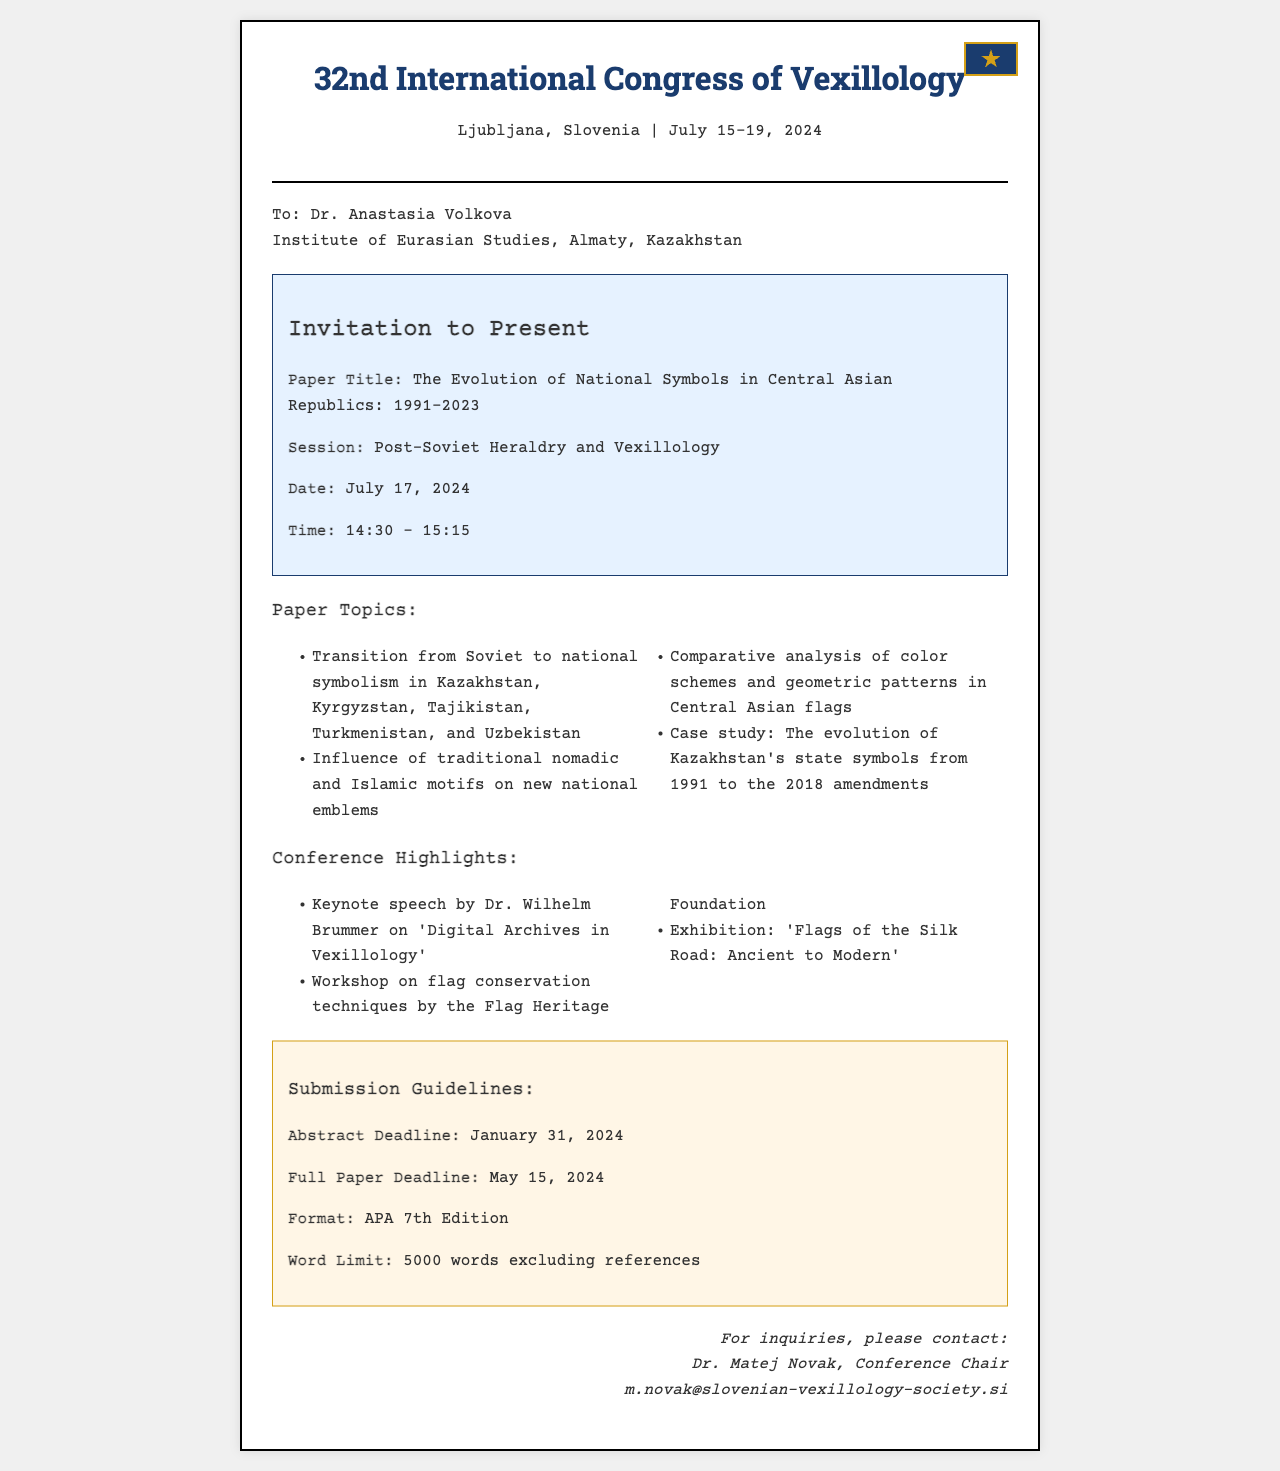What is the paper title? The title of the paper is mentioned in the invitation details as "The Evolution of National Symbols in Central Asian Republics: 1991-2023."
Answer: The Evolution of National Symbols in Central Asian Republics: 1991-2023 Who is the recipient of the invitation? The name and affiliation of the recipient, Dr. Anastasia Volkova, is stated in the document.
Answer: Dr. Anastasia Volkova What is the date of the conference? The document specifies the dates of the conference as "July 15-19, 2024."
Answer: July 15-19, 2024 What is the abstract deadline? The submission guidelines clearly mention the deadline for the abstract.
Answer: January 31, 2024 How long is the presentation scheduled for? The time allocated for the presentation is included in the invitation details.
Answer: 45 minutes What session is the paper part of? The session is specified in the invitation details as "Post-Soviet Heraldry and Vexillology."
Answer: Post-Soviet Heraldry and Vexillology Who is the contact person for inquiries? The document lists the contact person as Dr. Matej Novak for any inquiries.
Answer: Dr. Matej Novak What type of motifs are discussed in the paper topics? The paper topics reference "traditional nomadic and Islamic motifs" as part of the analysis.
Answer: traditional nomadic and Islamic motifs 